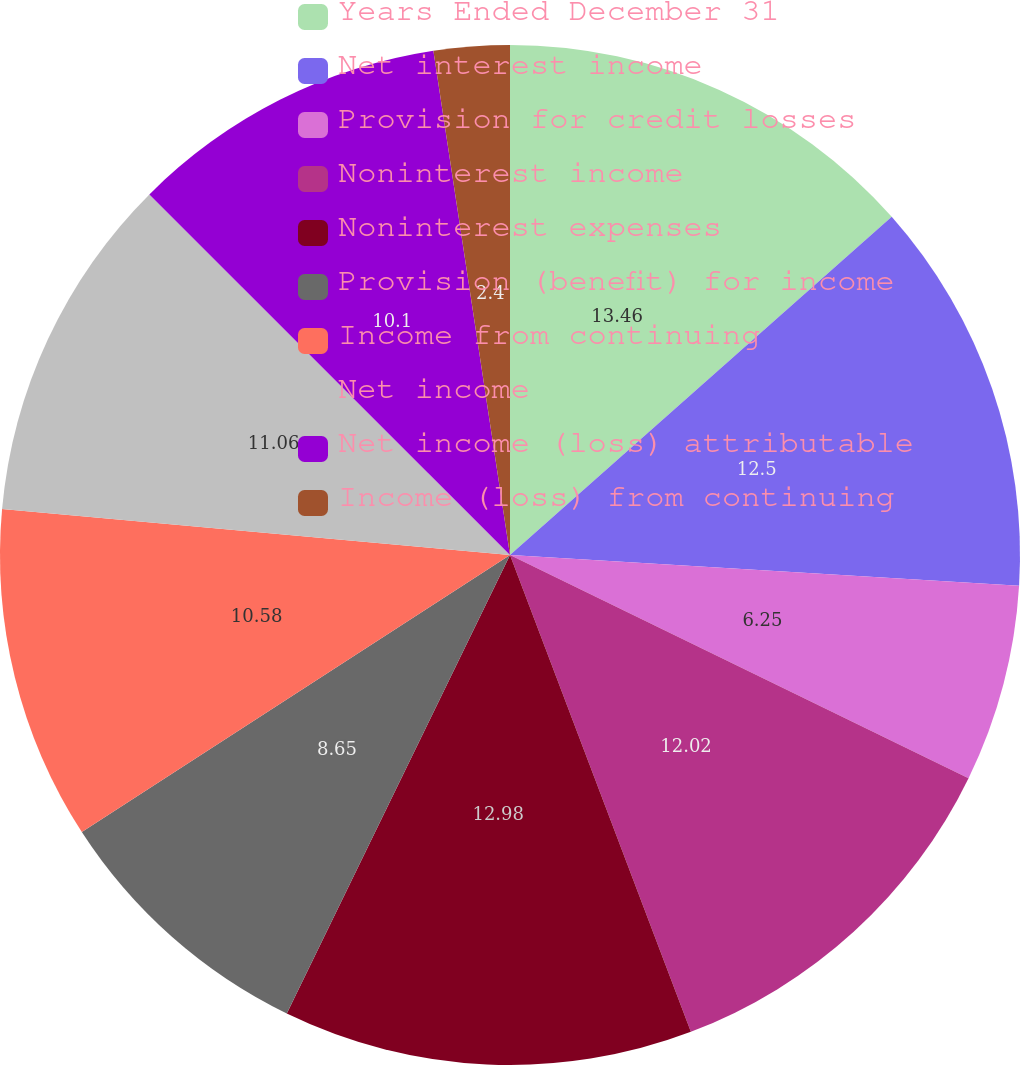Convert chart. <chart><loc_0><loc_0><loc_500><loc_500><pie_chart><fcel>Years Ended December 31<fcel>Net interest income<fcel>Provision for credit losses<fcel>Noninterest income<fcel>Noninterest expenses<fcel>Provision (benefit) for income<fcel>Income from continuing<fcel>Net income<fcel>Net income (loss) attributable<fcel>Income (loss) from continuing<nl><fcel>13.46%<fcel>12.5%<fcel>6.25%<fcel>12.02%<fcel>12.98%<fcel>8.65%<fcel>10.58%<fcel>11.06%<fcel>10.1%<fcel>2.4%<nl></chart> 